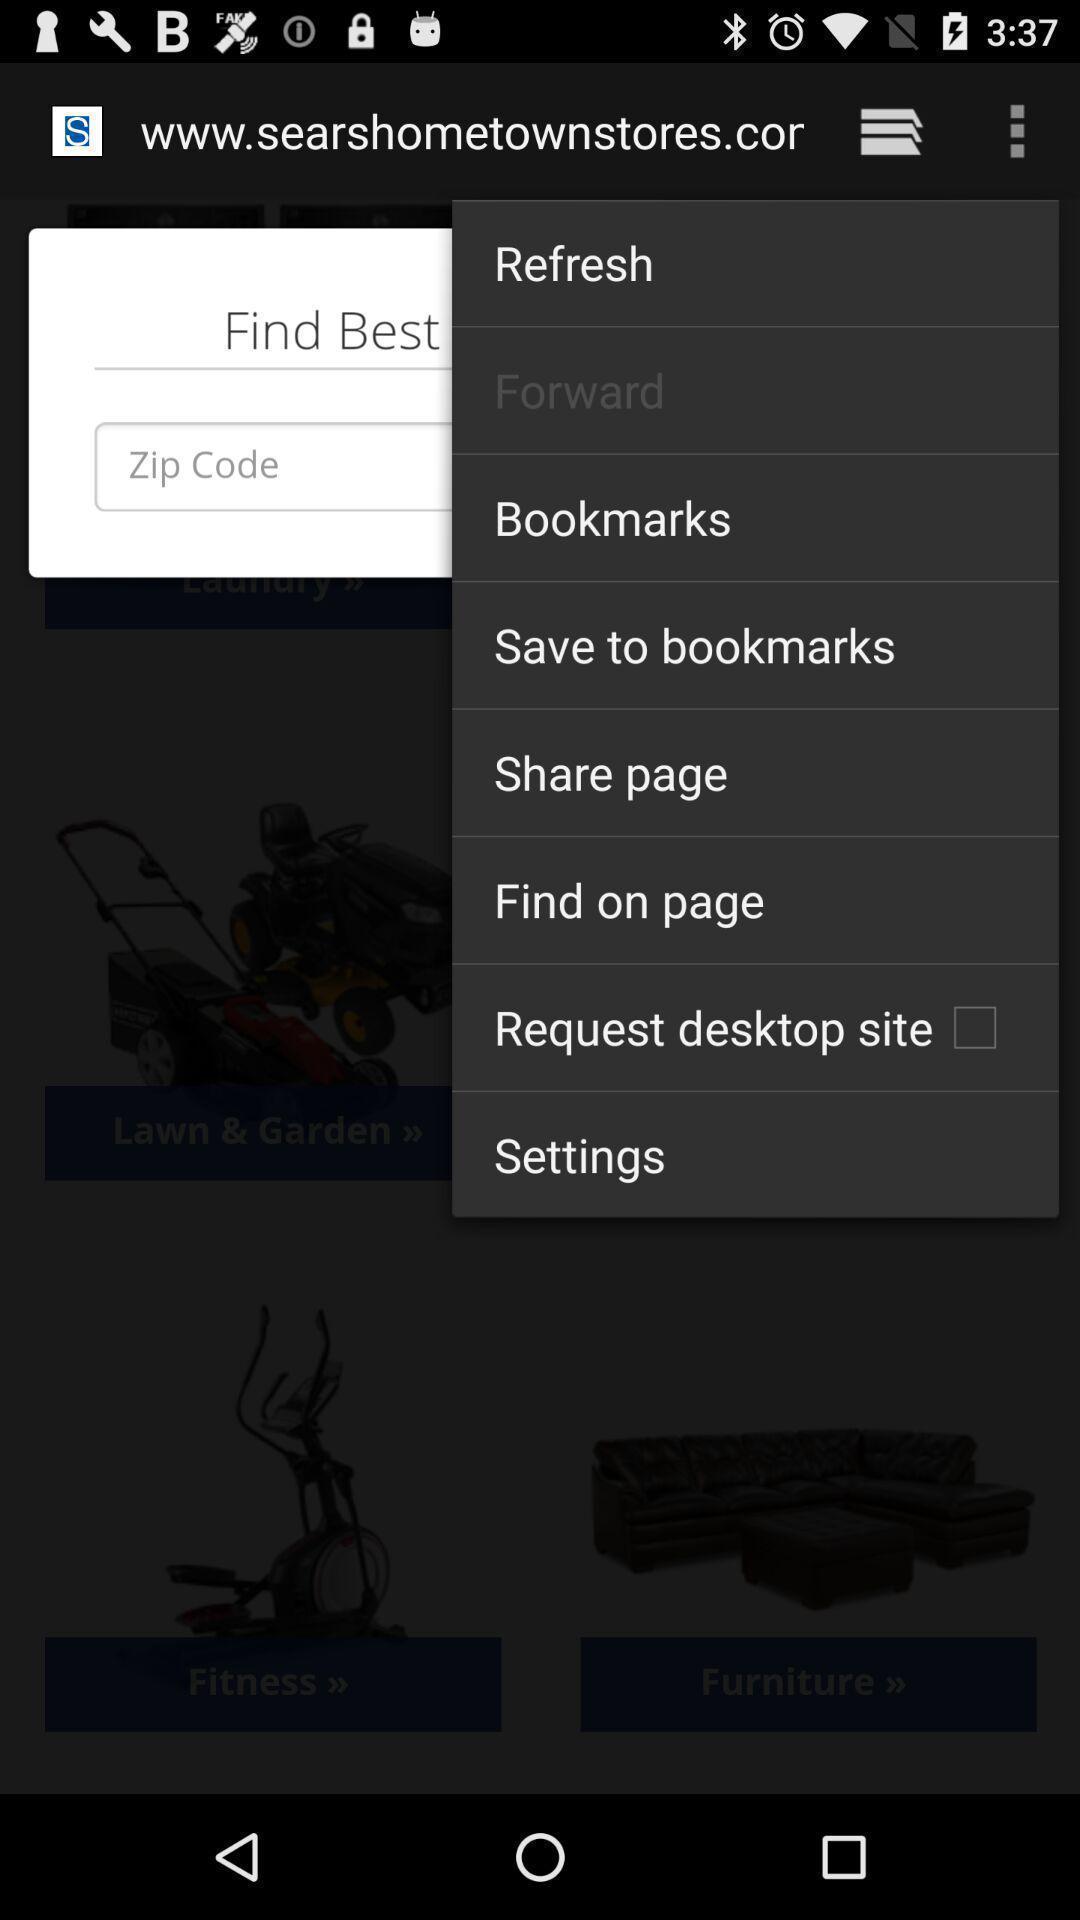What can you discern from this picture? Screen shows different options in a web page. 